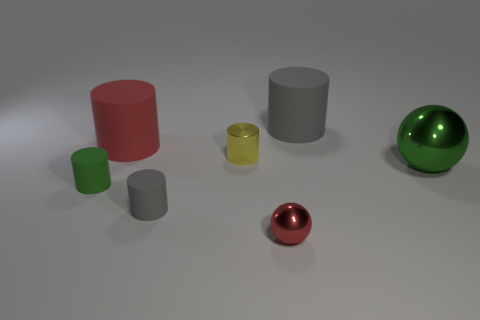Subtract all yellow cylinders. How many cylinders are left? 4 Subtract all red matte cylinders. How many cylinders are left? 4 Subtract all green cylinders. Subtract all brown spheres. How many cylinders are left? 4 Add 1 red matte things. How many objects exist? 8 Subtract all spheres. How many objects are left? 5 Add 3 small brown metal blocks. How many small brown metal blocks exist? 3 Subtract 0 yellow blocks. How many objects are left? 7 Subtract all large green metal spheres. Subtract all small rubber objects. How many objects are left? 4 Add 3 yellow things. How many yellow things are left? 4 